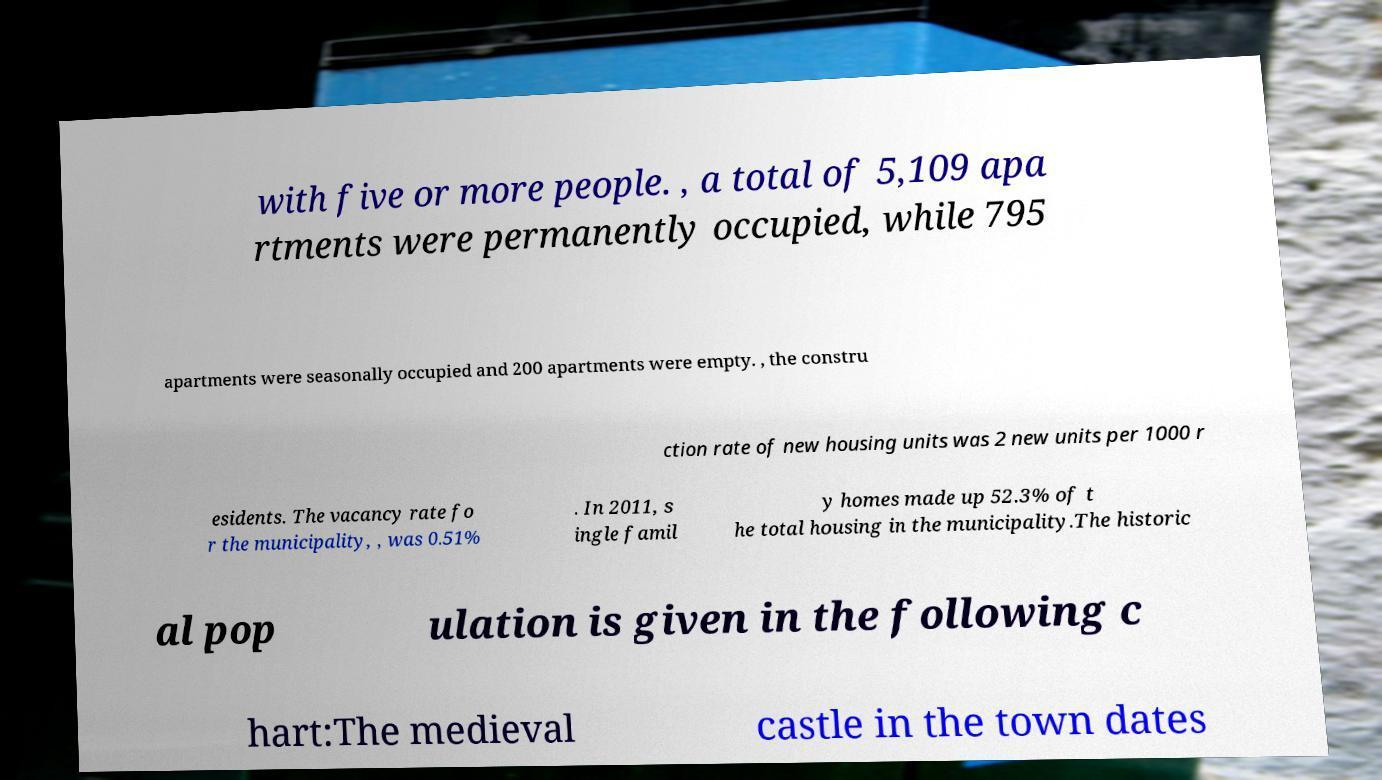Can you read and provide the text displayed in the image?This photo seems to have some interesting text. Can you extract and type it out for me? with five or more people. , a total of 5,109 apa rtments were permanently occupied, while 795 apartments were seasonally occupied and 200 apartments were empty. , the constru ction rate of new housing units was 2 new units per 1000 r esidents. The vacancy rate fo r the municipality, , was 0.51% . In 2011, s ingle famil y homes made up 52.3% of t he total housing in the municipality.The historic al pop ulation is given in the following c hart:The medieval castle in the town dates 